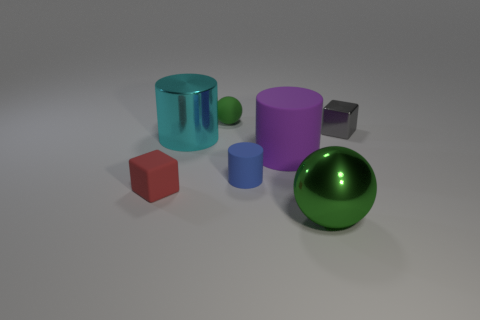Add 2 red objects. How many objects exist? 9 Subtract all big cylinders. How many cylinders are left? 1 Subtract 1 spheres. How many spheres are left? 1 Subtract all cylinders. How many objects are left? 4 Add 3 blue cylinders. How many blue cylinders are left? 4 Add 1 small gray metallic blocks. How many small gray metallic blocks exist? 2 Subtract all cyan cylinders. How many cylinders are left? 2 Subtract 2 green balls. How many objects are left? 5 Subtract all gray spheres. Subtract all red cubes. How many spheres are left? 2 Subtract all cyan spheres. How many gray cubes are left? 1 